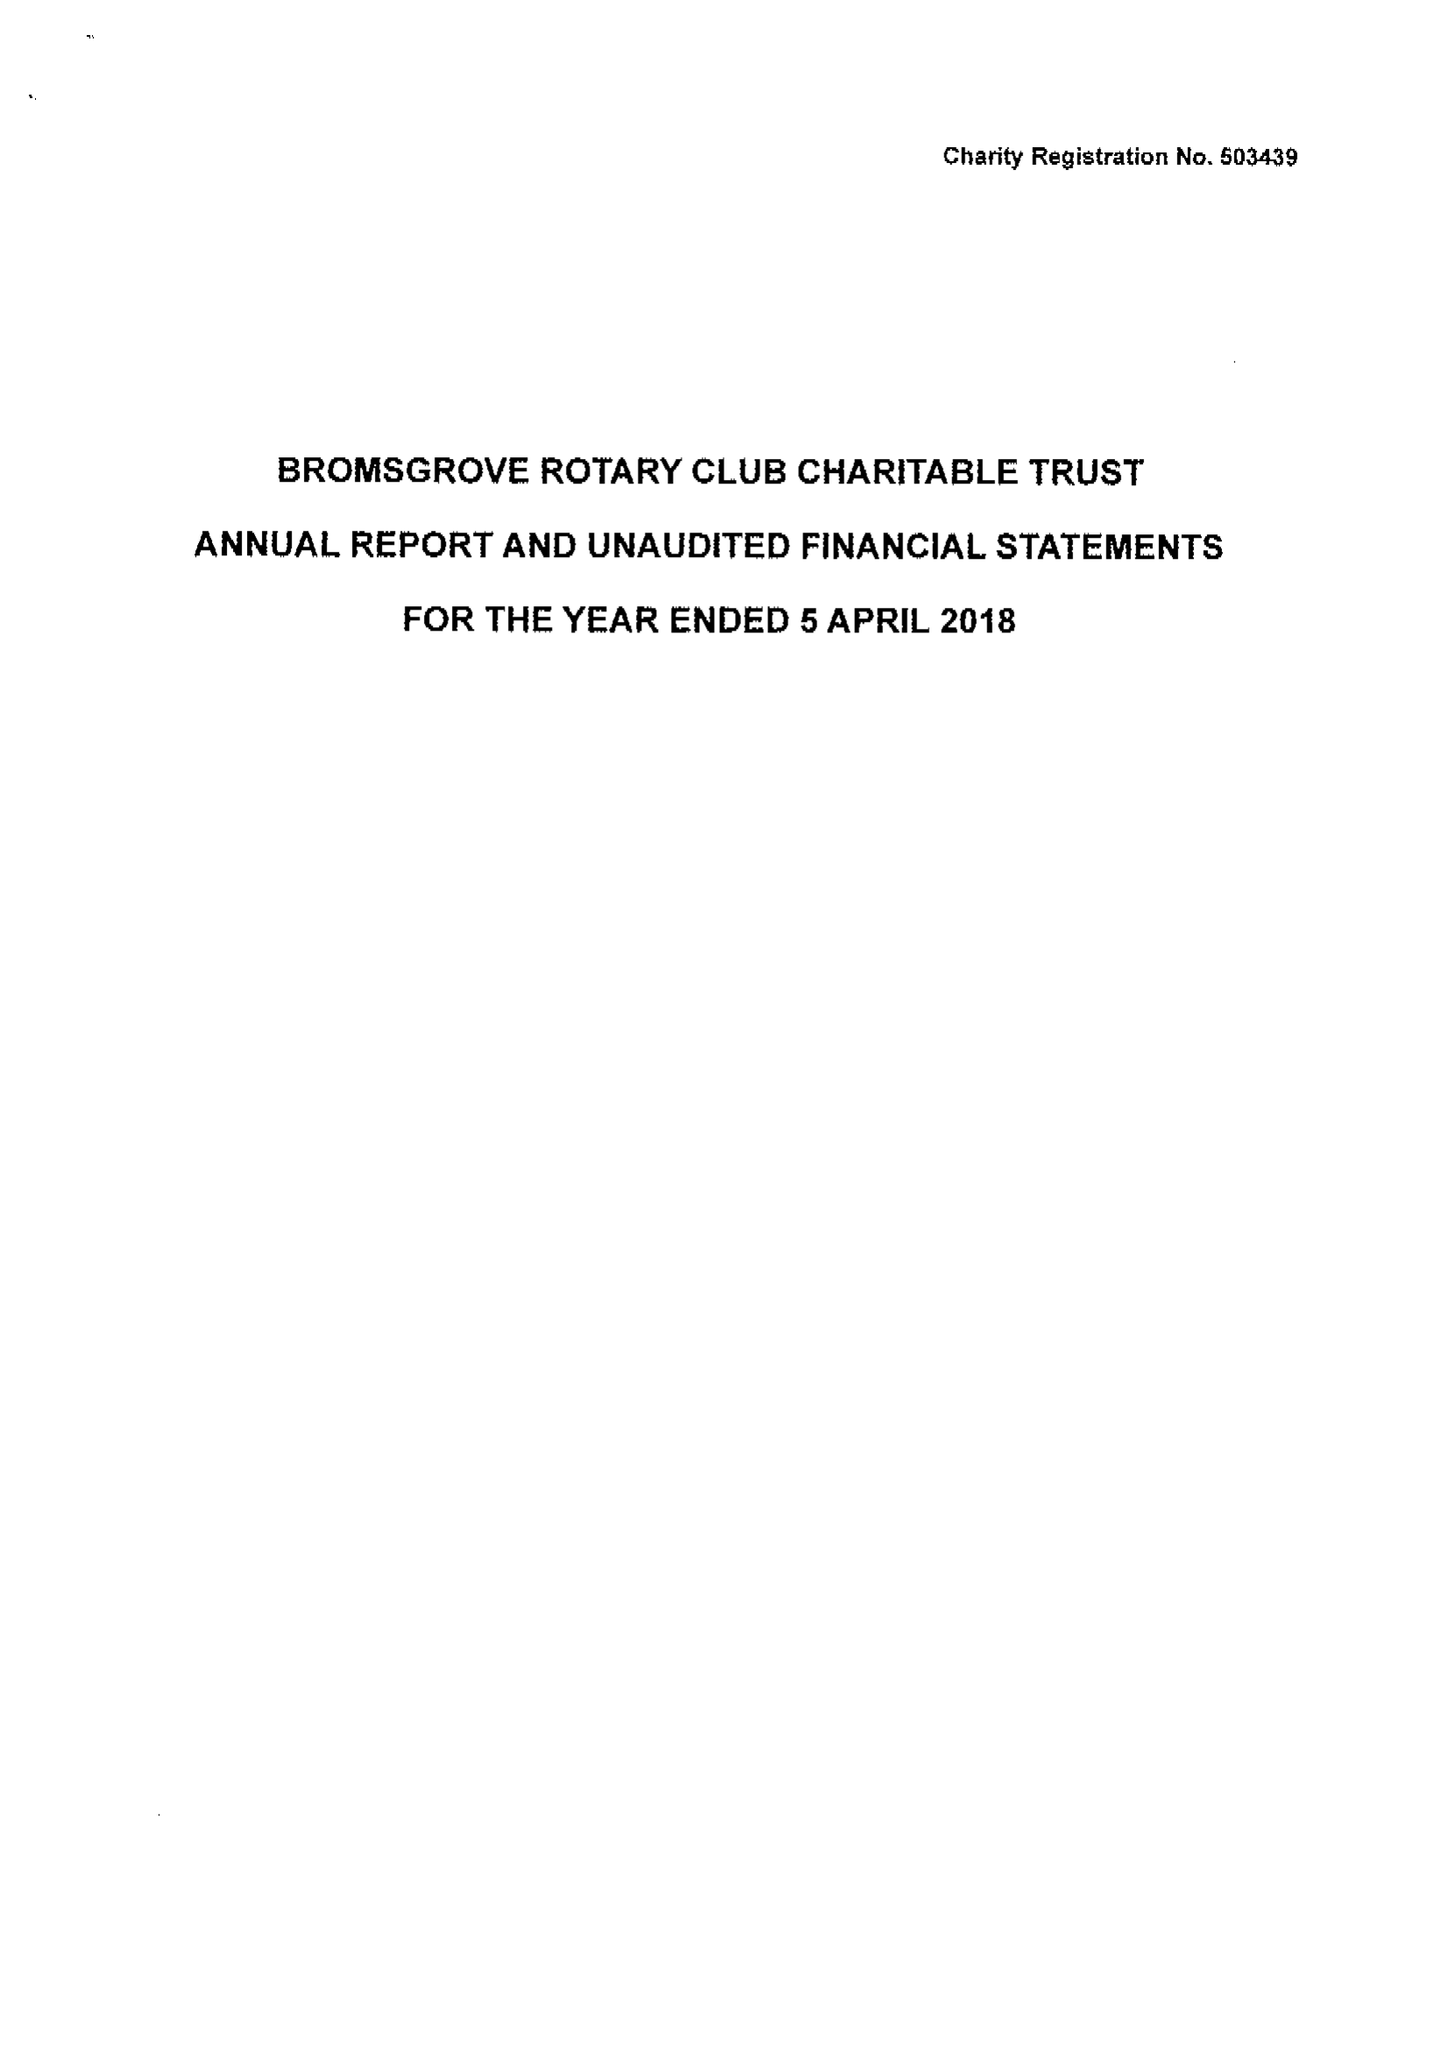What is the value for the address__post_town?
Answer the question using a single word or phrase. BROMSGROVE 